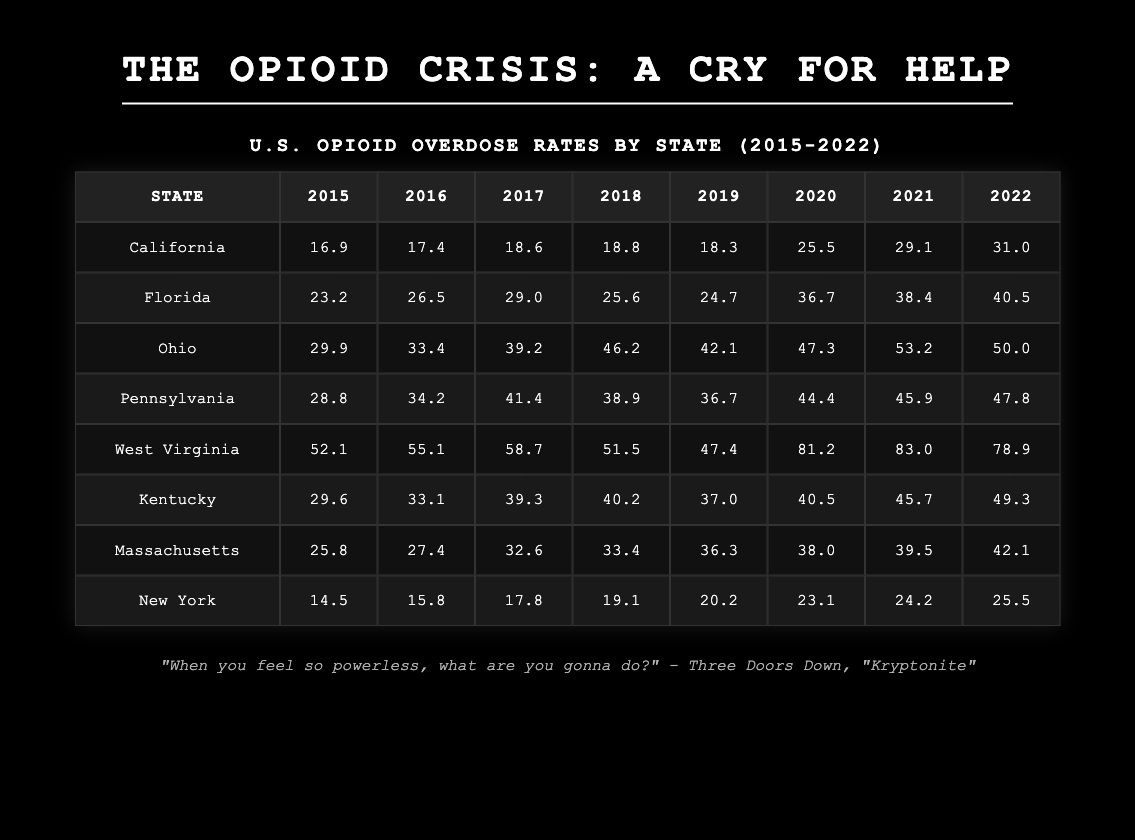What was the opioid overdose rate in Ohio in 2017? The table shows that Ohio's overdose rate in 2017 is listed directly next to the state in that row, which is 39.2.
Answer: 39.2 Which state had the highest opioid overdose rate in 2020? Looking at the 2020 column in the table, West Virginia has the highest rate listed at 81.2.
Answer: West Virginia What is the difference in opioid overdose rates between California and Florida in 2021? The overdose rate for California in 2021 is 29.1, and for Florida, it is 38.4. The difference is calculated as 38.4 - 29.1 = 9.3.
Answer: 9.3 Which state experienced a decrease in opioid overdose rates from 2018 to 2019? By reviewing the data for each state, West Virginia decreased from 51.5 in 2018 to 47.4 in 2019, which confirms a decrease.
Answer: West Virginia What is the average opioid overdose rate for Massachusetts from 2015 to 2022? To find the average, sum the rates: (25.8 + 27.4 + 32.6 + 33.4 + 36.3 + 38.0 + 39.5 + 42.1) = 335.1. Then divide by 8 (the number of years) resulting in an average of 335.1 / 8 = 41.89.
Answer: 41.89 Does New York have an overdose rate higher than the national average of 30 in 2022? New York's overdose rate in 2022 is 25.5, which is below the national average of 30, confirming this statement as false.
Answer: No Which state's overdose rate in 2021 was closest to the rate of Massachusetts in the same year? Massachusetts had a rate of 39.5 in 2021, and Kentucky's rate of 45.7 is the closest but higher compared to other states. Thus, Kentucky is the answer.
Answer: Kentucky How many states had an opioid overdose rate of over 40 in 2021? By inspecting the 2021 column, Florida (38.4), Ohio (53.2), Pennsylvania (45.9), West Virginia (83.0), Kentucky (45.7), and Massachusetts (39.5), only Florida does not exceed 40. Thus, there are five states above that threshold.
Answer: 5 What trend can be observed in West Virginia's overdose rates from 2015 to 2022? By looking at West Virginia's rates from 52.1 in 2015 and rising to 78.9 in 2022, it can be observed that there is a significant upward trend in overdose rates.
Answer: Increasing trend 